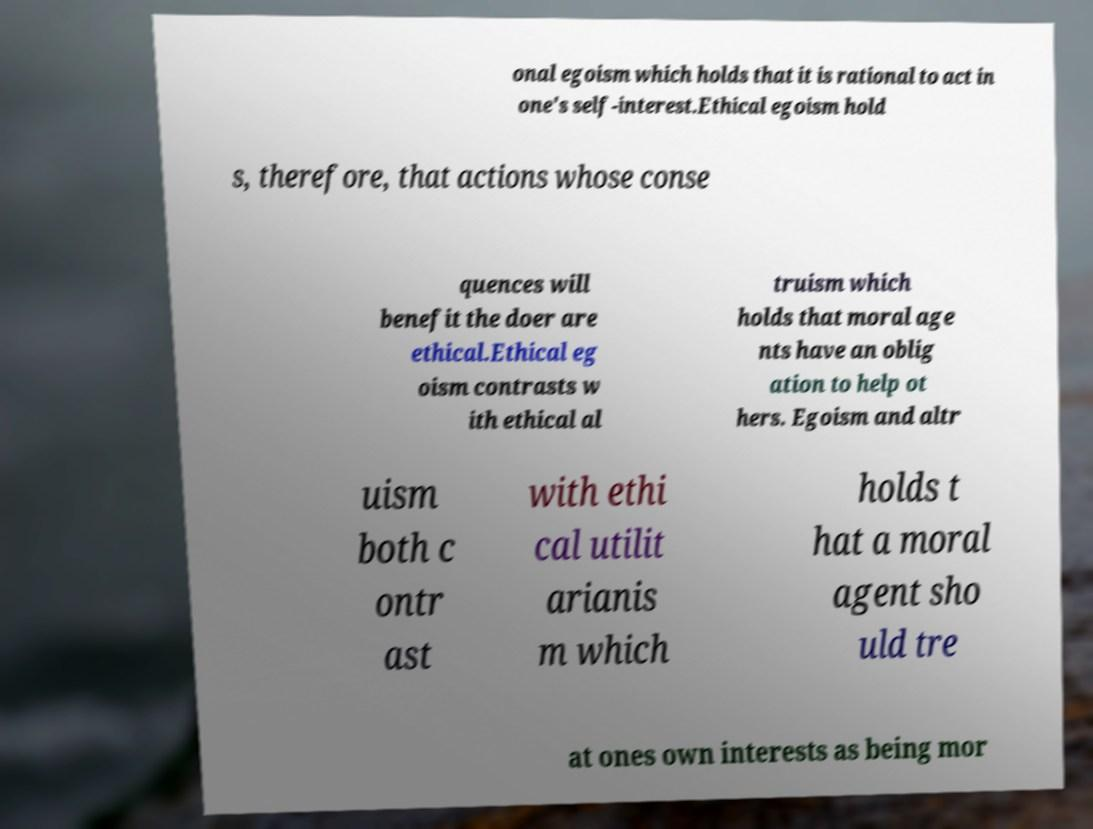Can you accurately transcribe the text from the provided image for me? onal egoism which holds that it is rational to act in one's self-interest.Ethical egoism hold s, therefore, that actions whose conse quences will benefit the doer are ethical.Ethical eg oism contrasts w ith ethical al truism which holds that moral age nts have an oblig ation to help ot hers. Egoism and altr uism both c ontr ast with ethi cal utilit arianis m which holds t hat a moral agent sho uld tre at ones own interests as being mor 